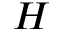Convert formula to latex. <formula><loc_0><loc_0><loc_500><loc_500>H</formula> 